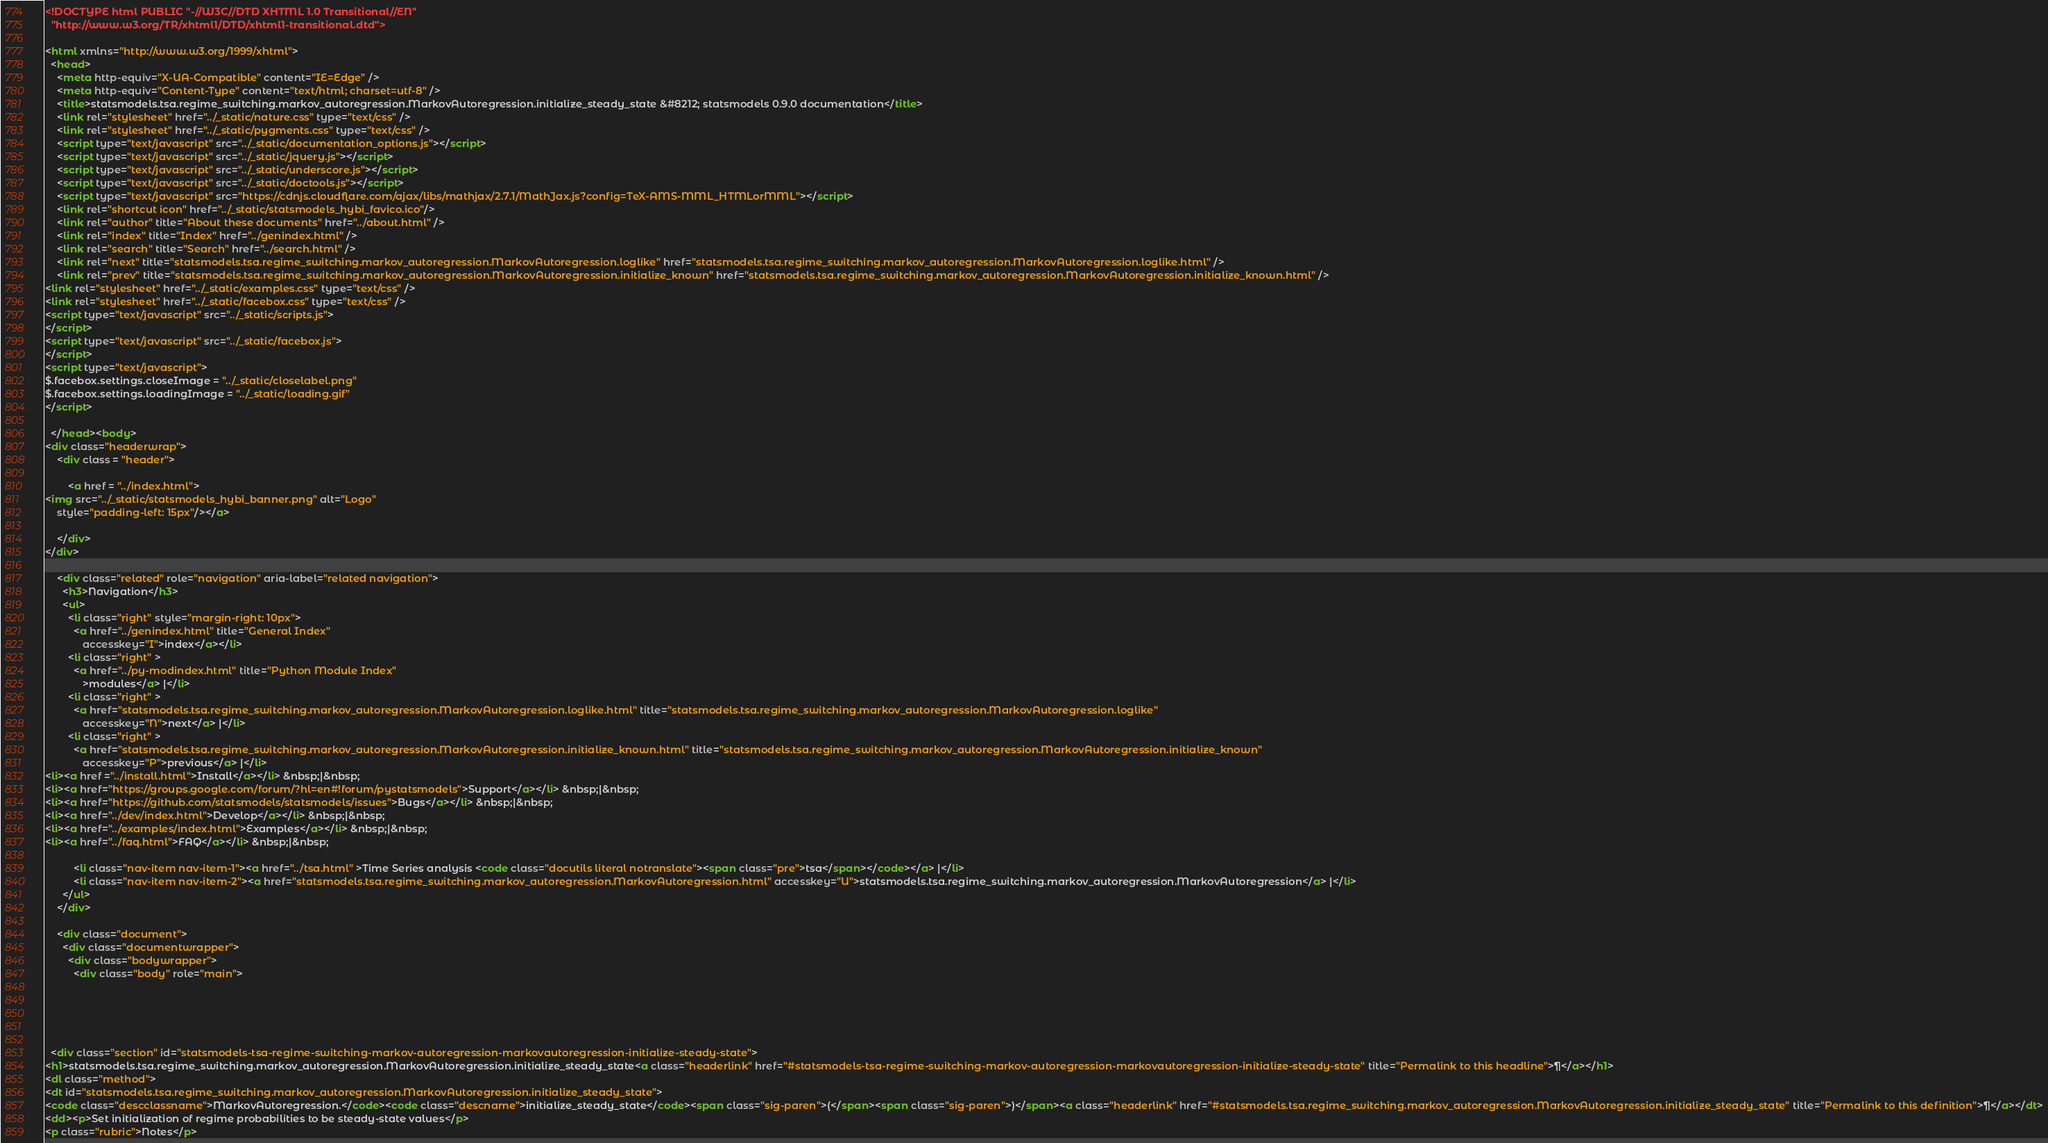Convert code to text. <code><loc_0><loc_0><loc_500><loc_500><_HTML_>

<!DOCTYPE html PUBLIC "-//W3C//DTD XHTML 1.0 Transitional//EN"
  "http://www.w3.org/TR/xhtml1/DTD/xhtml1-transitional.dtd">

<html xmlns="http://www.w3.org/1999/xhtml">
  <head>
    <meta http-equiv="X-UA-Compatible" content="IE=Edge" />
    <meta http-equiv="Content-Type" content="text/html; charset=utf-8" />
    <title>statsmodels.tsa.regime_switching.markov_autoregression.MarkovAutoregression.initialize_steady_state &#8212; statsmodels 0.9.0 documentation</title>
    <link rel="stylesheet" href="../_static/nature.css" type="text/css" />
    <link rel="stylesheet" href="../_static/pygments.css" type="text/css" />
    <script type="text/javascript" src="../_static/documentation_options.js"></script>
    <script type="text/javascript" src="../_static/jquery.js"></script>
    <script type="text/javascript" src="../_static/underscore.js"></script>
    <script type="text/javascript" src="../_static/doctools.js"></script>
    <script type="text/javascript" src="https://cdnjs.cloudflare.com/ajax/libs/mathjax/2.7.1/MathJax.js?config=TeX-AMS-MML_HTMLorMML"></script>
    <link rel="shortcut icon" href="../_static/statsmodels_hybi_favico.ico"/>
    <link rel="author" title="About these documents" href="../about.html" />
    <link rel="index" title="Index" href="../genindex.html" />
    <link rel="search" title="Search" href="../search.html" />
    <link rel="next" title="statsmodels.tsa.regime_switching.markov_autoregression.MarkovAutoregression.loglike" href="statsmodels.tsa.regime_switching.markov_autoregression.MarkovAutoregression.loglike.html" />
    <link rel="prev" title="statsmodels.tsa.regime_switching.markov_autoregression.MarkovAutoregression.initialize_known" href="statsmodels.tsa.regime_switching.markov_autoregression.MarkovAutoregression.initialize_known.html" />
<link rel="stylesheet" href="../_static/examples.css" type="text/css" />
<link rel="stylesheet" href="../_static/facebox.css" type="text/css" />
<script type="text/javascript" src="../_static/scripts.js">
</script>
<script type="text/javascript" src="../_static/facebox.js">
</script>
<script type="text/javascript">
$.facebox.settings.closeImage = "../_static/closelabel.png"
$.facebox.settings.loadingImage = "../_static/loading.gif"
</script>

  </head><body>
<div class="headerwrap">
    <div class = "header">
        
        <a href = "../index.html">
<img src="../_static/statsmodels_hybi_banner.png" alt="Logo"
    style="padding-left: 15px"/></a>
        
    </div>
</div>

    <div class="related" role="navigation" aria-label="related navigation">
      <h3>Navigation</h3>
      <ul>
        <li class="right" style="margin-right: 10px">
          <a href="../genindex.html" title="General Index"
             accesskey="I">index</a></li>
        <li class="right" >
          <a href="../py-modindex.html" title="Python Module Index"
             >modules</a> |</li>
        <li class="right" >
          <a href="statsmodels.tsa.regime_switching.markov_autoregression.MarkovAutoregression.loglike.html" title="statsmodels.tsa.regime_switching.markov_autoregression.MarkovAutoregression.loglike"
             accesskey="N">next</a> |</li>
        <li class="right" >
          <a href="statsmodels.tsa.regime_switching.markov_autoregression.MarkovAutoregression.initialize_known.html" title="statsmodels.tsa.regime_switching.markov_autoregression.MarkovAutoregression.initialize_known"
             accesskey="P">previous</a> |</li>
<li><a href ="../install.html">Install</a></li> &nbsp;|&nbsp;
<li><a href="https://groups.google.com/forum/?hl=en#!forum/pystatsmodels">Support</a></li> &nbsp;|&nbsp;
<li><a href="https://github.com/statsmodels/statsmodels/issues">Bugs</a></li> &nbsp;|&nbsp;
<li><a href="../dev/index.html">Develop</a></li> &nbsp;|&nbsp;
<li><a href="../examples/index.html">Examples</a></li> &nbsp;|&nbsp;
<li><a href="../faq.html">FAQ</a></li> &nbsp;|&nbsp;

          <li class="nav-item nav-item-1"><a href="../tsa.html" >Time Series analysis <code class="docutils literal notranslate"><span class="pre">tsa</span></code></a> |</li>
          <li class="nav-item nav-item-2"><a href="statsmodels.tsa.regime_switching.markov_autoregression.MarkovAutoregression.html" accesskey="U">statsmodels.tsa.regime_switching.markov_autoregression.MarkovAutoregression</a> |</li> 
      </ul>
    </div>  

    <div class="document">
      <div class="documentwrapper">
        <div class="bodywrapper">
          <div class="body" role="main">
            




  <div class="section" id="statsmodels-tsa-regime-switching-markov-autoregression-markovautoregression-initialize-steady-state">
<h1>statsmodels.tsa.regime_switching.markov_autoregression.MarkovAutoregression.initialize_steady_state<a class="headerlink" href="#statsmodels-tsa-regime-switching-markov-autoregression-markovautoregression-initialize-steady-state" title="Permalink to this headline">¶</a></h1>
<dl class="method">
<dt id="statsmodels.tsa.regime_switching.markov_autoregression.MarkovAutoregression.initialize_steady_state">
<code class="descclassname">MarkovAutoregression.</code><code class="descname">initialize_steady_state</code><span class="sig-paren">(</span><span class="sig-paren">)</span><a class="headerlink" href="#statsmodels.tsa.regime_switching.markov_autoregression.MarkovAutoregression.initialize_steady_state" title="Permalink to this definition">¶</a></dt>
<dd><p>Set initialization of regime probabilities to be steady-state values</p>
<p class="rubric">Notes</p></code> 